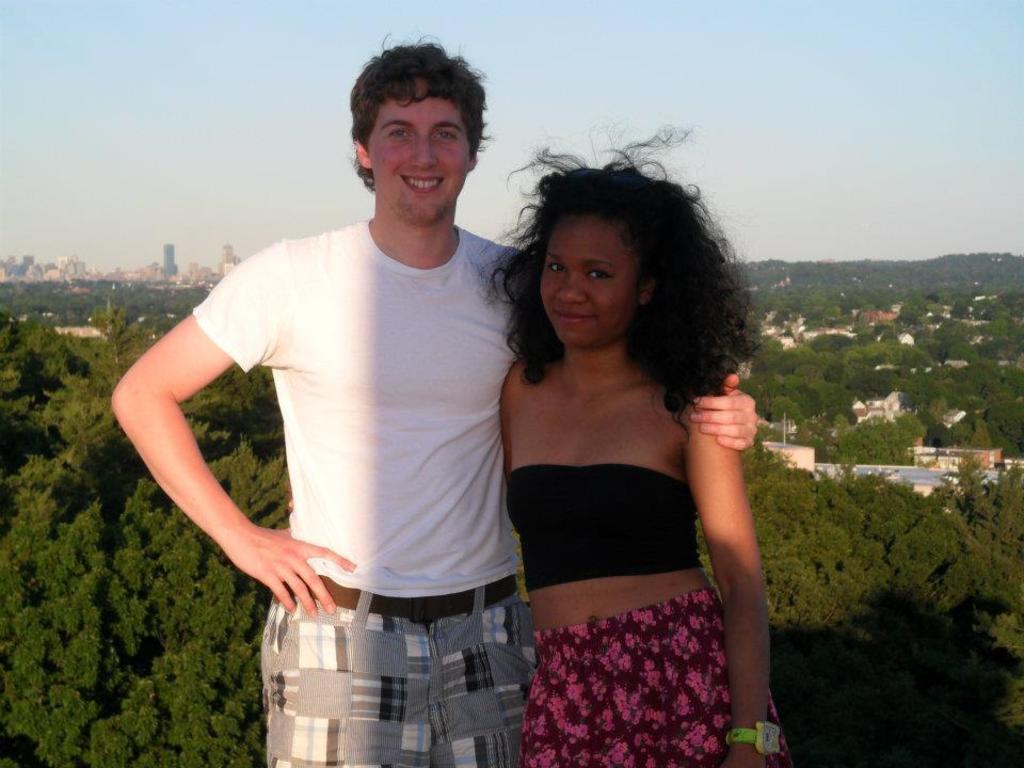Could you give a brief overview of what you see in this image? In the image there is a man and woman, both are posing for the photo and behind them there are many trees and houses. 